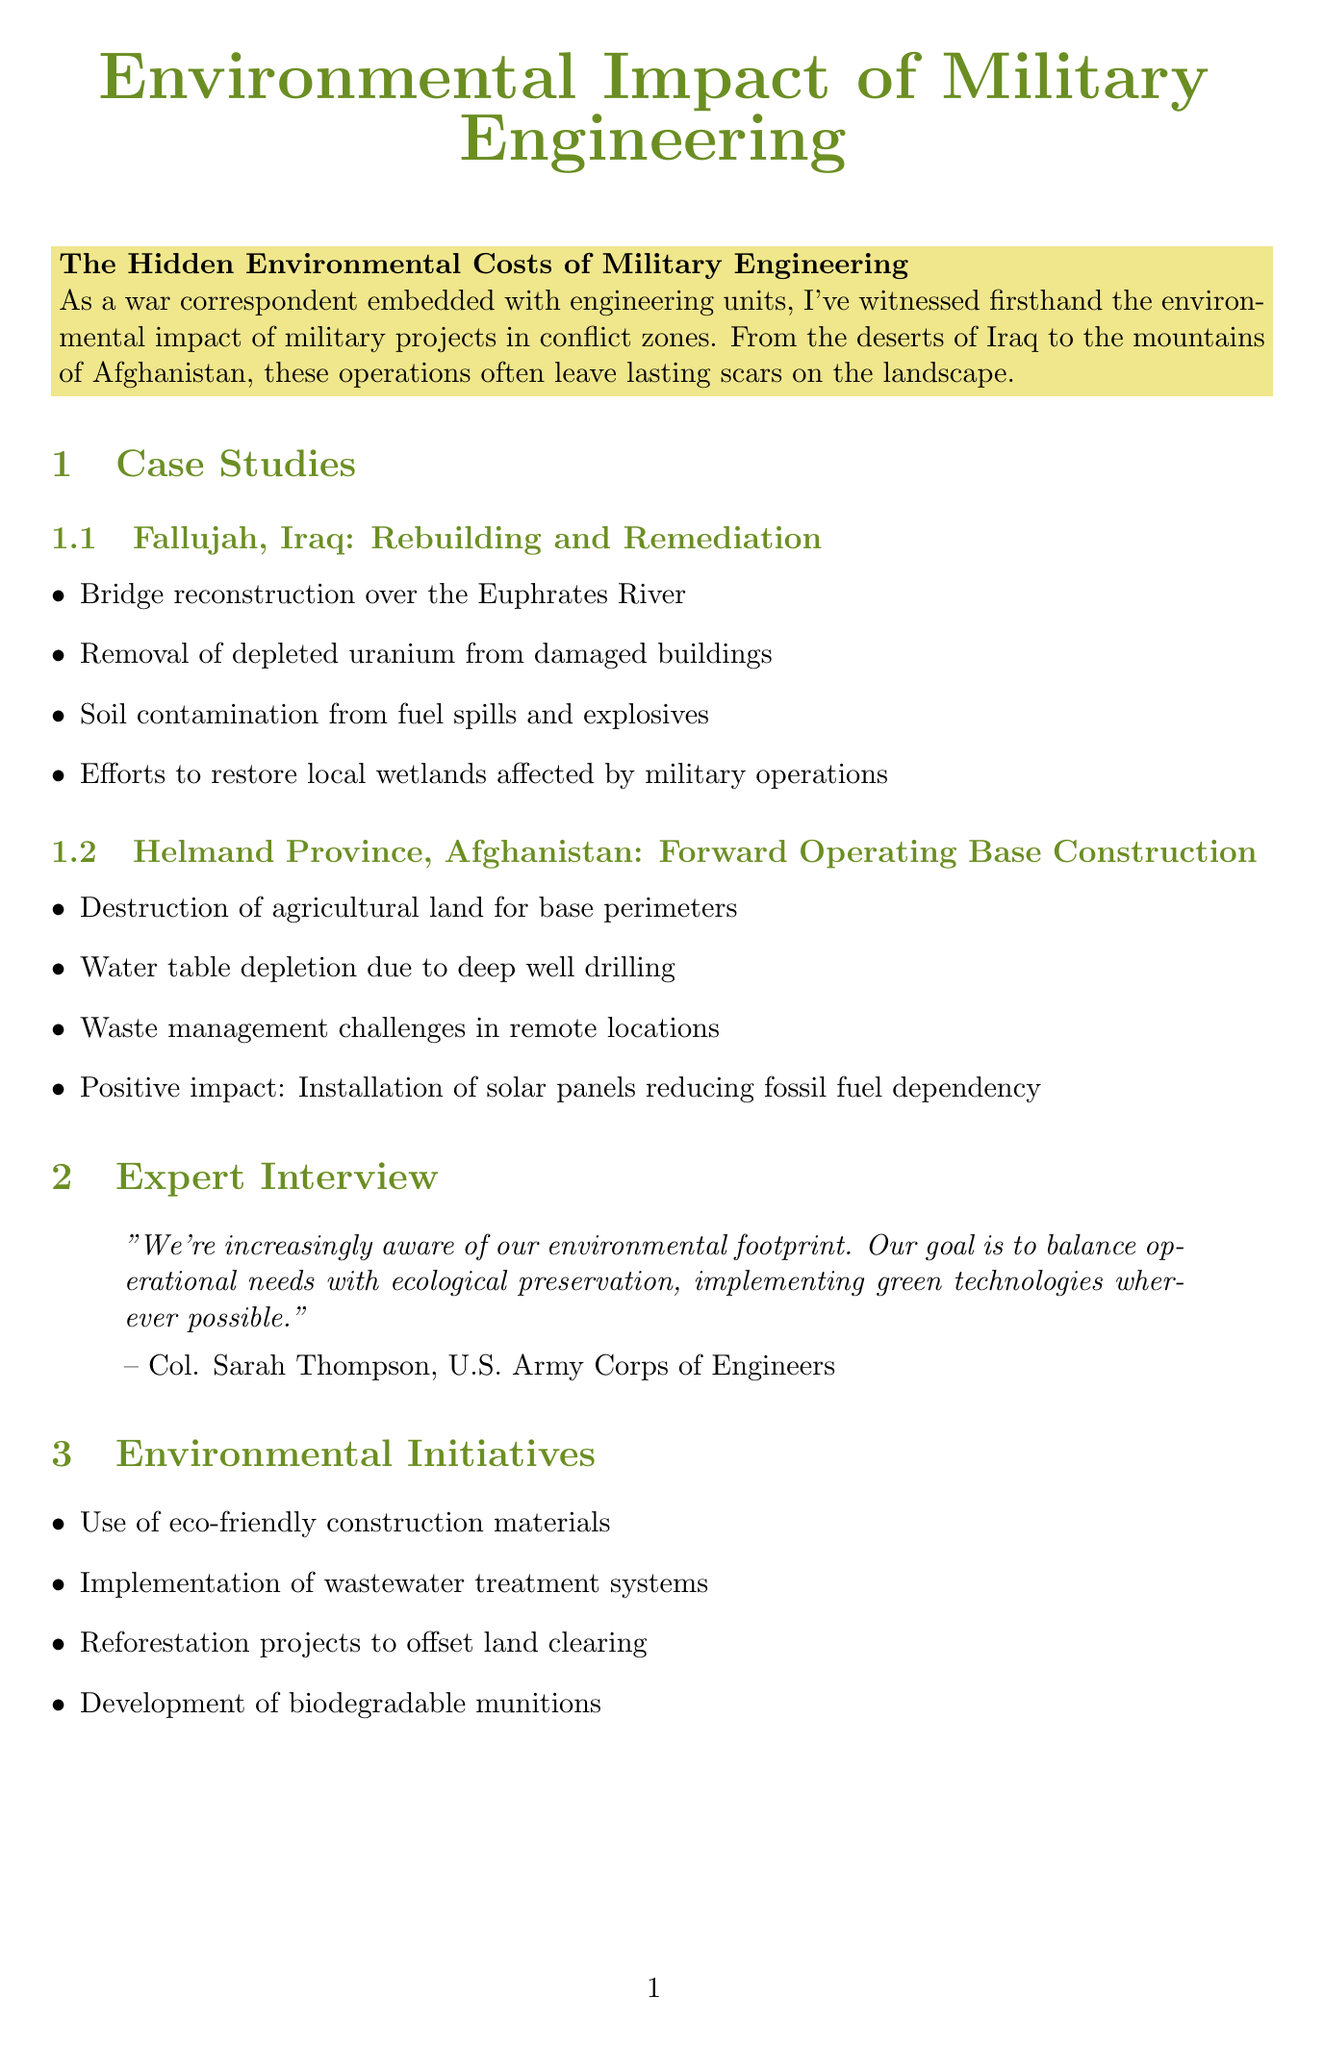what is the title of the first case study? The title of the first case study is listed under "case_study_1" in the document.
Answer: Rebuilding and Remediation what environmental issue was tackled in Fallujah? This question refers to specific details outlined in the first case study of the document.
Answer: Soil contamination what renewable energy solution was implemented in Helmand Province? The document mentions a specific positive environmental initiative related to energy in Helmand Province.
Answer: Solar panels who is the subject of the expert interview? This question refers to the information provided in the "Expert Interview" section of the newsletter.
Answer: Col. Sarah Thompson what is one of the environmental initiatives mentioned? The document lists several initiatives under "Environmental Initiatives," which can be used to answer this question.
Answer: Eco-friendly construction materials which conflict zone is highlighted for base construction? The second case study provides this specific information about the conflict zone.
Answer: Helmand Province what challenge is associated with unexploded ordnance? This question refers to the challenges listed in the "Challenges" section of the document.
Answer: Post-conflict restoration what is the future outlook described in the newsletter? The document provides insights into future trends in military engineering under "Future Outlook."
Answer: Green Military Engineering what environmental concern is prioritized in military engineering, according to Col. Sarah Thompson? The expert interview includes a quote emphasizing the focus of military engineering efforts.
Answer: Ecological preservation 